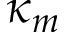<formula> <loc_0><loc_0><loc_500><loc_500>\kappa _ { m }</formula> 